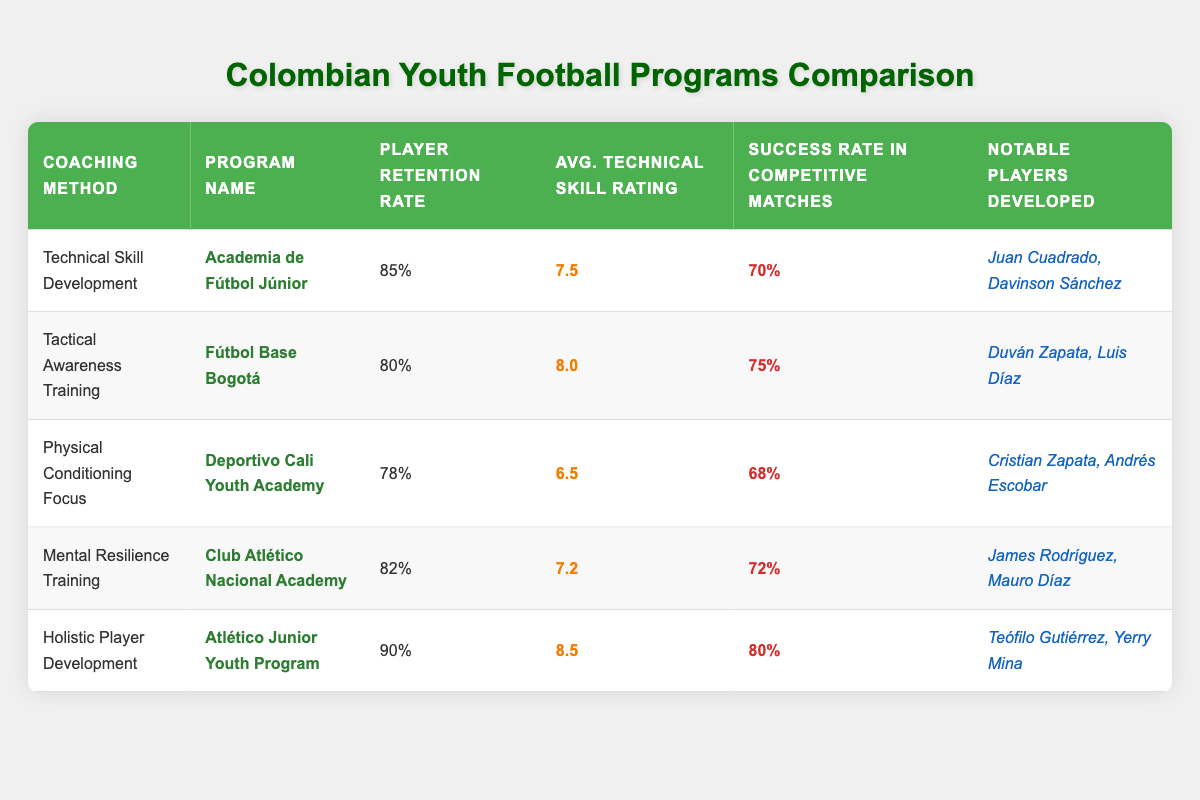What is the player retention rate for Holistic Player Development? The player retention rate for Holistic Player Development is listed in the table under the “Player Retention Rate” column for Atlético Junior Youth Program. The rate is 90%.
Answer: 90% Which coaching method has the highest average technical skill rating? Looking at the average technical skill ratings for each coaching method in the table, Holistic Player Development has the highest rating of 8.5 for Atlético Junior Youth Program.
Answer: 8.5 Did Deportivo Cali Youth Academy have a success rate in competitive matches of over 70%? Checking the success rate in competitive matches for Deportivo Cali Youth Academy, it is listed as 68%, which is not greater than 70%.
Answer: No What is the average player retention rate across all coaching methods? To find the average player retention rate, sum the rates from each method: (85 + 80 + 78 + 82 + 90) = 415. Then divide by the number of methods: 415 / 5 = 83.
Answer: 83 What notable players were developed under the Tactical Awareness Training coaching method? Referring to the table, the notable players developed under the Tactical Awareness Training method from Fútbol Base Bogotá are Duván Zapata and Luis Díaz.
Answer: Duván Zapata, Luis Díaz Which coaching method is associated with the lowest player retention rate? By reviewing the “Player Retention Rate” column, Physical Conditioning Focus from Deportivo Cali Youth Academy has the lowest rate of 78%.
Answer: Physical Conditioning Focus Is the success rate in competitive matches for Mental Resilience Training greater than that of Tactical Awareness Training? The success rate for Mental Resilience Training is 72%, while for Tactical Awareness Training it is 75%. Since 72% is less than 75%, the statement is false.
Answer: No What is the difference in success rates between Holistic Player Development and Technical Skill Development? The success rate for Holistic Player Development is 80%, and for Technical Skill Development, it is 70%. Therefore, the difference is 80 - 70 = 10.
Answer: 10 How many notable players were developed by Club Atlético Nacional Academy? According to the table, Club Atlético Nacional Academy developed two notable players: James Rodríguez and Mauro Díaz. Therefore, the count is 2.
Answer: 2 